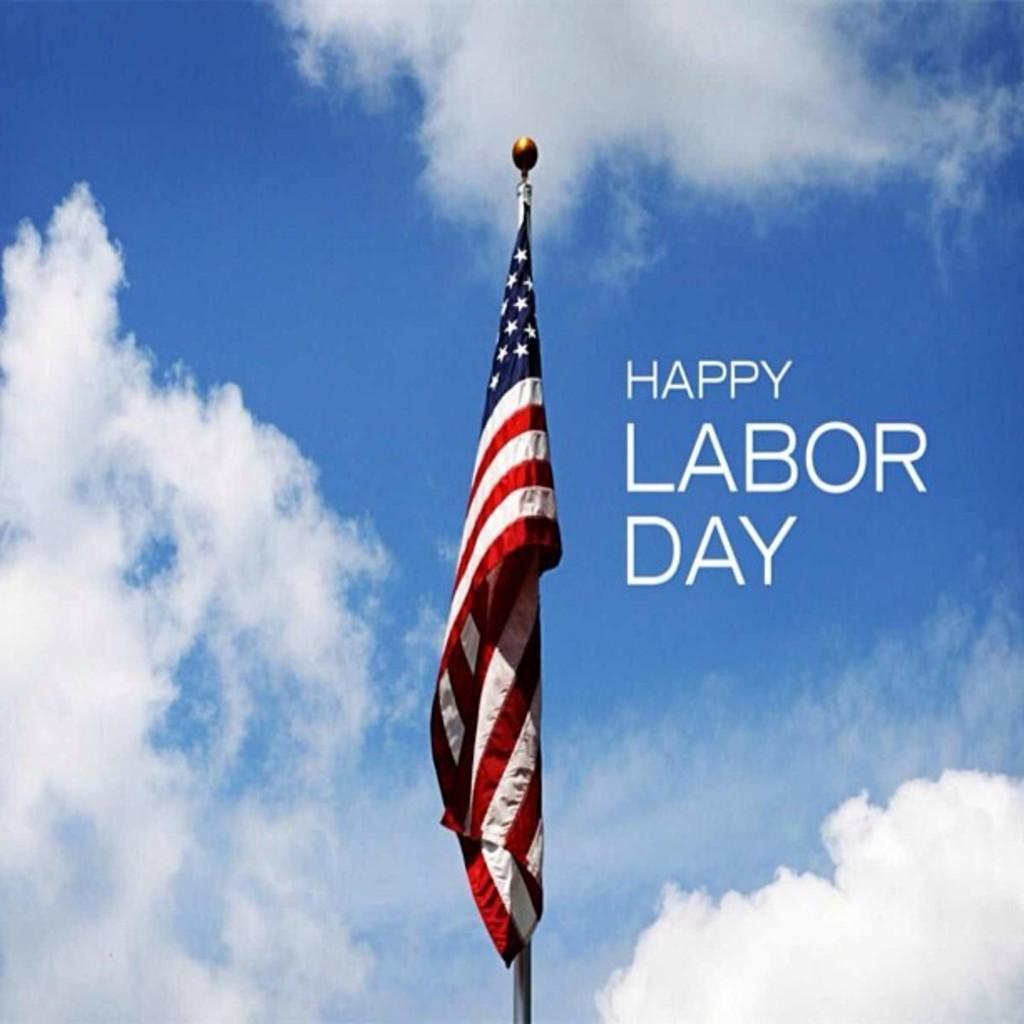Can you describe this image briefly? This is an edited image in this image there is an american flag to a pole, beside the it is written as happy labour day in the background there is a blue sky with clouds. 